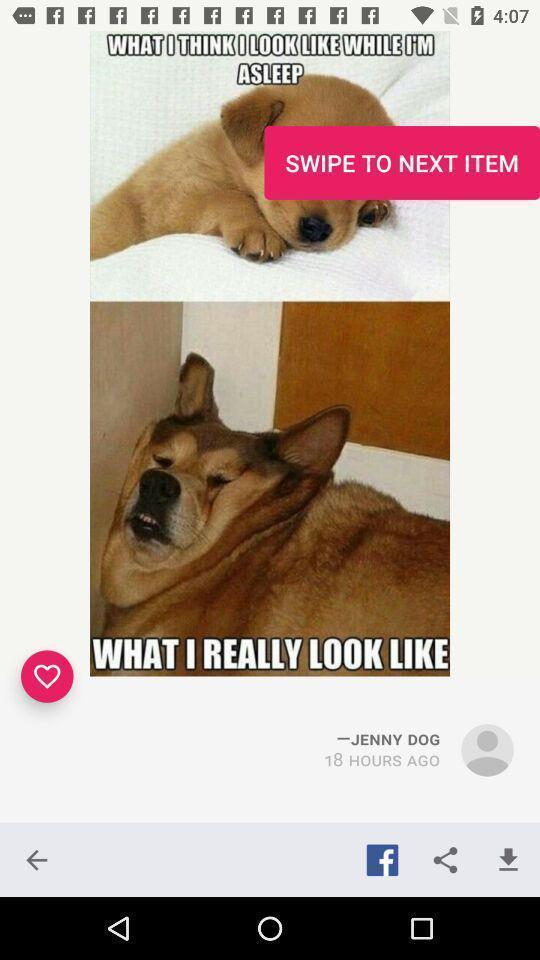Tell me about the visual elements in this screen capture. Window displaying a quote to share. 